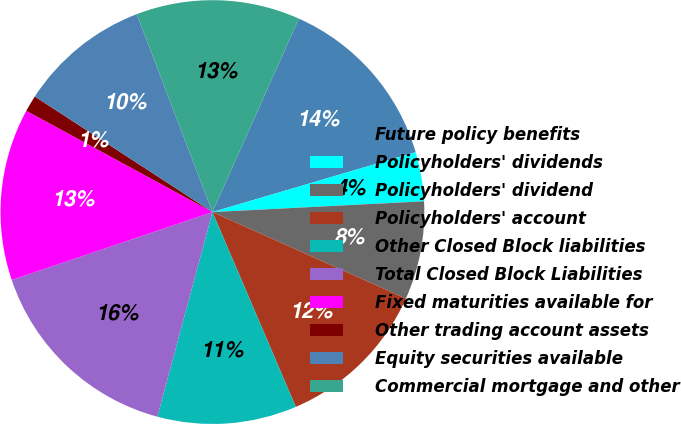Convert chart to OTSL. <chart><loc_0><loc_0><loc_500><loc_500><pie_chart><fcel>Future policy benefits<fcel>Policyholders' dividends<fcel>Policyholders' dividend<fcel>Policyholders' account<fcel>Other Closed Block liabilities<fcel>Total Closed Block Liabilities<fcel>Fixed maturities available for<fcel>Other trading account assets<fcel>Equity securities available<fcel>Commercial mortgage and other<nl><fcel>13.75%<fcel>3.75%<fcel>7.5%<fcel>11.87%<fcel>10.62%<fcel>15.62%<fcel>13.12%<fcel>1.25%<fcel>10.0%<fcel>12.5%<nl></chart> 